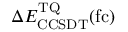<formula> <loc_0><loc_0><loc_500><loc_500>\Delta E _ { C C S D T } ^ { T Q } ( f c )</formula> 